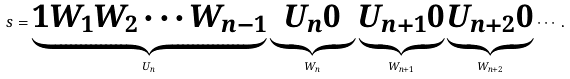Convert formula to latex. <formula><loc_0><loc_0><loc_500><loc_500>\ s = \underbrace { 1 W _ { 1 } W _ { 2 } \cdots W _ { n - 1 } } _ { U _ { n } } \underbrace { U _ { n } 0 } _ { W _ { n } } \underbrace { U _ { n + 1 } 0 } _ { W _ { n + 1 } } \underbrace { U _ { n + 2 } 0 } _ { W _ { n + 2 } } \cdots .</formula> 